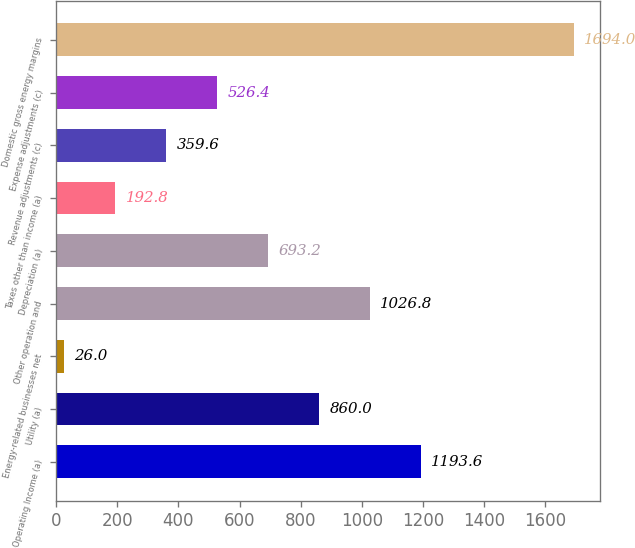<chart> <loc_0><loc_0><loc_500><loc_500><bar_chart><fcel>Operating Income (a)<fcel>Utility (a)<fcel>Energy-related businesses net<fcel>Other operation and<fcel>Depreciation (a)<fcel>Taxes other than income (a)<fcel>Revenue adjustments (c)<fcel>Expense adjustments (c)<fcel>Domestic gross energy margins<nl><fcel>1193.6<fcel>860<fcel>26<fcel>1026.8<fcel>693.2<fcel>192.8<fcel>359.6<fcel>526.4<fcel>1694<nl></chart> 